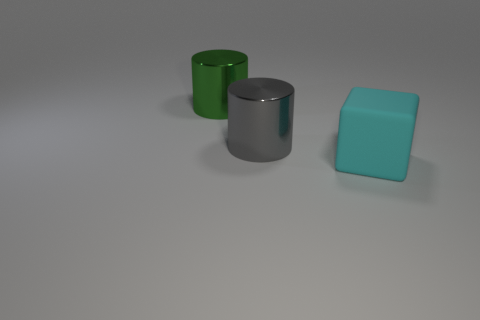Is there anything else that is the same material as the block?
Make the answer very short. No. How big is the cylinder on the right side of the large shiny cylinder that is left of the gray metal cylinder?
Make the answer very short. Large. There is a object behind the metallic cylinder that is to the right of the big metal cylinder on the left side of the big gray metallic cylinder; what size is it?
Keep it short and to the point. Large. There is a large object behind the gray cylinder; does it have the same shape as the large shiny thing in front of the green shiny thing?
Make the answer very short. Yes. Is the size of the thing in front of the gray metal cylinder the same as the large gray cylinder?
Ensure brevity in your answer.  Yes. Does the big cylinder in front of the large green thing have the same material as the cylinder that is behind the gray cylinder?
Offer a very short reply. Yes. Is there a green cylinder that has the same size as the cyan matte block?
Provide a succinct answer. Yes. There is a large cyan thing that is to the right of the cylinder that is on the right side of the cylinder on the left side of the large gray cylinder; what shape is it?
Provide a short and direct response. Cube. Is the number of green metallic objects that are to the right of the matte thing greater than the number of big matte things?
Ensure brevity in your answer.  No. Is there a large gray metal thing of the same shape as the green metal object?
Make the answer very short. Yes. 